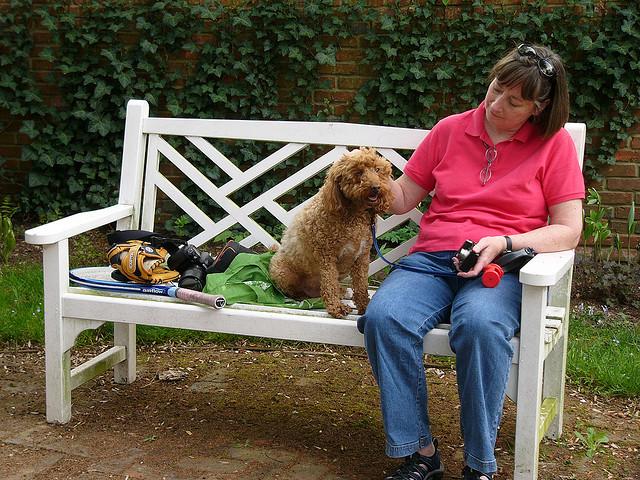Is the background wall made of brick?
Answer briefly. Yes. What is the dog doing on the lady?
Keep it brief. Sitting. How many pairs of jeans do you see?
Write a very short answer. 1. How many glasses does the woman have?
Write a very short answer. 1. Is the dog about to eat?
Be succinct. No. 